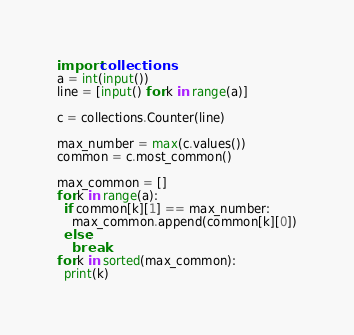<code> <loc_0><loc_0><loc_500><loc_500><_Python_>import collections
a = int(input())
line = [input() for k in range(a)]
 
c = collections.Counter(line)
 
max_number = max(c.values())
common = c.most_common()
 
max_common = []
for k in range(a):
  if common[k][1] == max_number:
    max_common.append(common[k][0])
  else:
    break
for k in sorted(max_common):
  print(k)</code> 